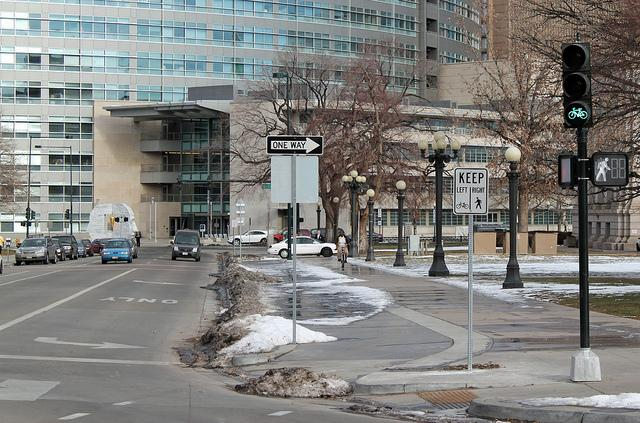What natural event seems to have occurred here?

Choices:
A) hurricane
B) thunder
C) snow
D) tornado snow 